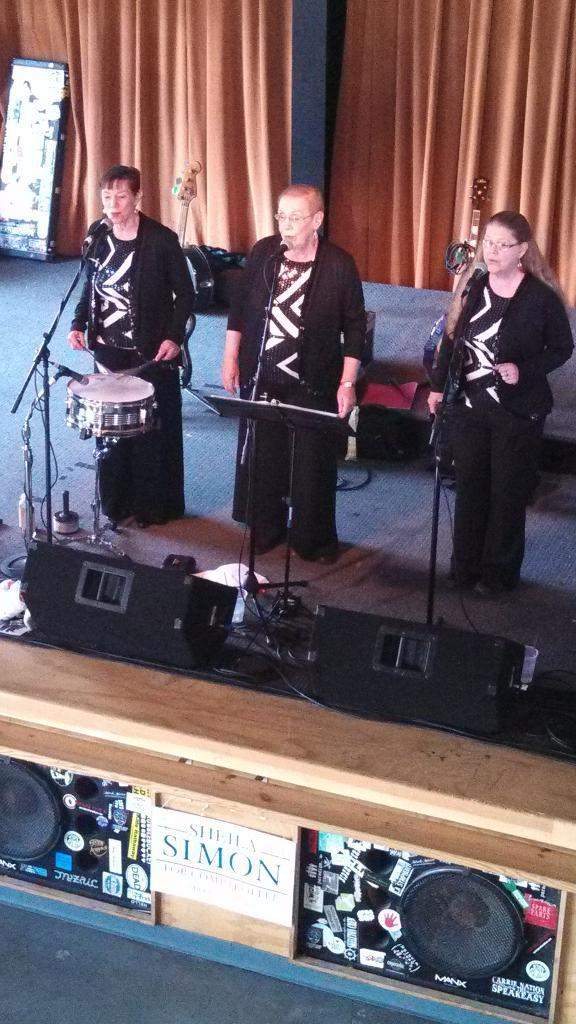How many people are in the image? There are three women in the image. What are the women doing in the image? The women are performing and playing musical instruments. How are the women amplifying their voices in the image? The women are using microphones. What can be seen behind the women in the image? There are curtains visible behind the women. What type of growth can be seen on the women's instruments in the image? There is no visible growth on the women's instruments in the image. What riddle is the women trying to solve in the image? There is no riddle present in the image; the women are performing and playing musical instruments. 